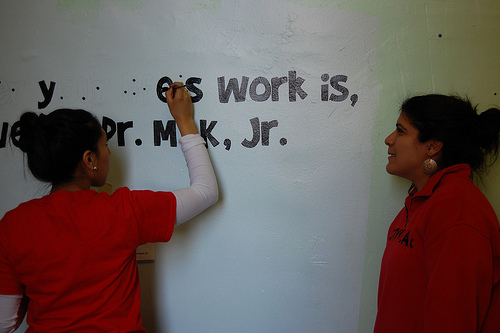<image>
Is the woman to the right of the woman? Yes. From this viewpoint, the woman is positioned to the right side relative to the woman. 